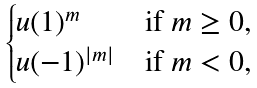Convert formula to latex. <formula><loc_0><loc_0><loc_500><loc_500>\begin{cases} u ( 1 ) ^ { m } & \text {if } m \geq 0 , \\ u ( - 1 ) ^ { | m | } & \text {if } m < 0 , \\ \end{cases}</formula> 